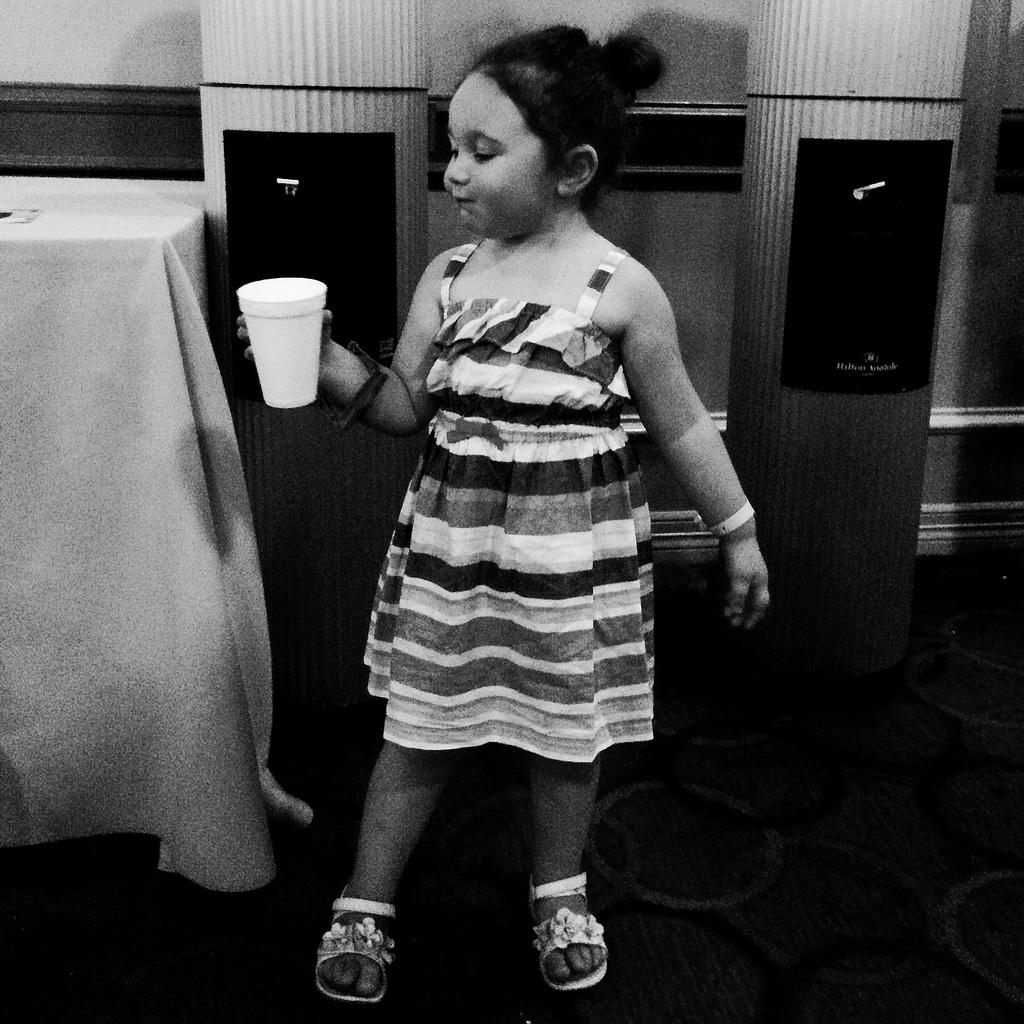Who is the main subject in the image? There is a girl in the image. What is the girl doing in the image? The girl is standing in the image. What is the girl holding in the image? The girl is holding a glass in the image. What is the color scheme of the image? The image is black and white in color. How many dimes can be seen on the ground in the image? There are no dimes visible on the ground in the image. What type of spot is present on the girl's shirt in the image? There is no spot visible on the girl's shirt in the image. 